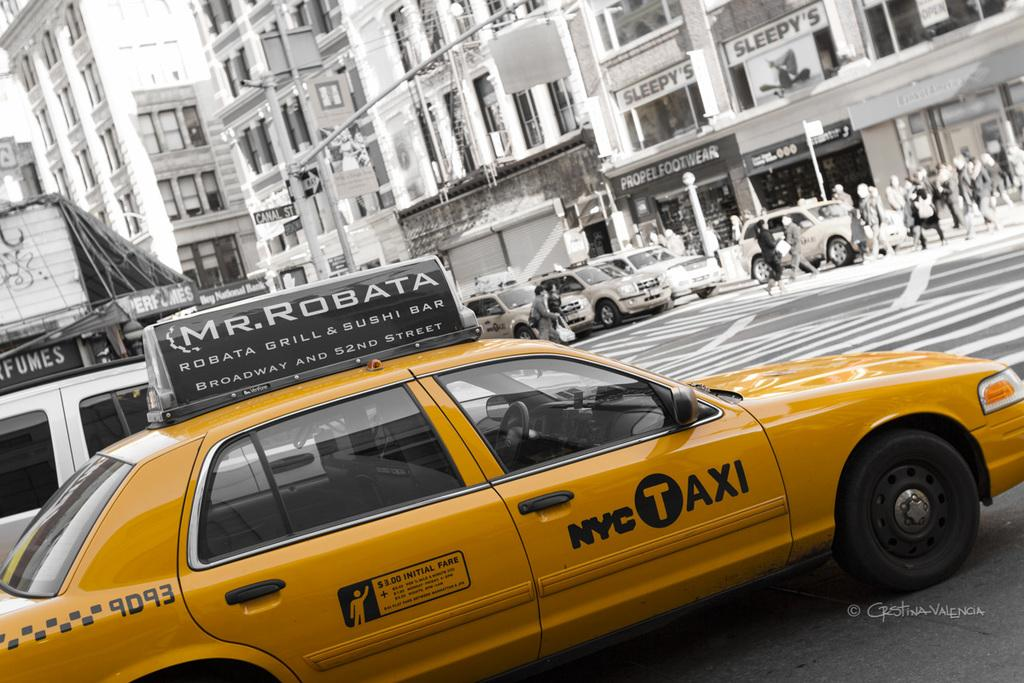<image>
Create a compact narrative representing the image presented. A yellow NYC taxi cab with a Mr. Robata advert on top. 